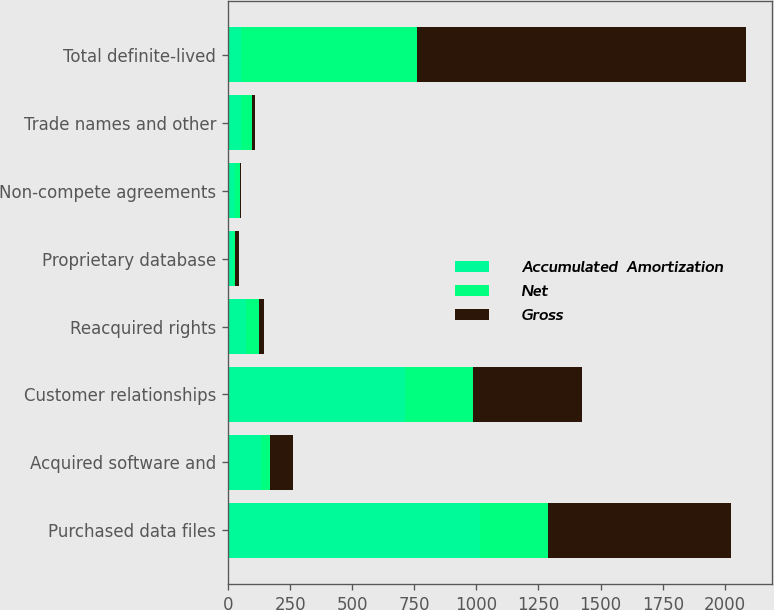<chart> <loc_0><loc_0><loc_500><loc_500><stacked_bar_chart><ecel><fcel>Purchased data files<fcel>Acquired software and<fcel>Customer relationships<fcel>Reacquired rights<fcel>Proprietary database<fcel>Non-compete agreements<fcel>Trade names and other<fcel>Total definite-lived<nl><fcel>Accumulated  Amortization<fcel>1012.7<fcel>131.5<fcel>712.7<fcel>73.3<fcel>21.5<fcel>26.8<fcel>54.1<fcel>54.1<nl><fcel>Net<fcel>276<fcel>36.1<fcel>273<fcel>52.5<fcel>6.7<fcel>22.2<fcel>42.3<fcel>708.8<nl><fcel>Gross<fcel>736.7<fcel>95.4<fcel>439.7<fcel>20.8<fcel>14.8<fcel>4.6<fcel>11.8<fcel>1323.8<nl></chart> 